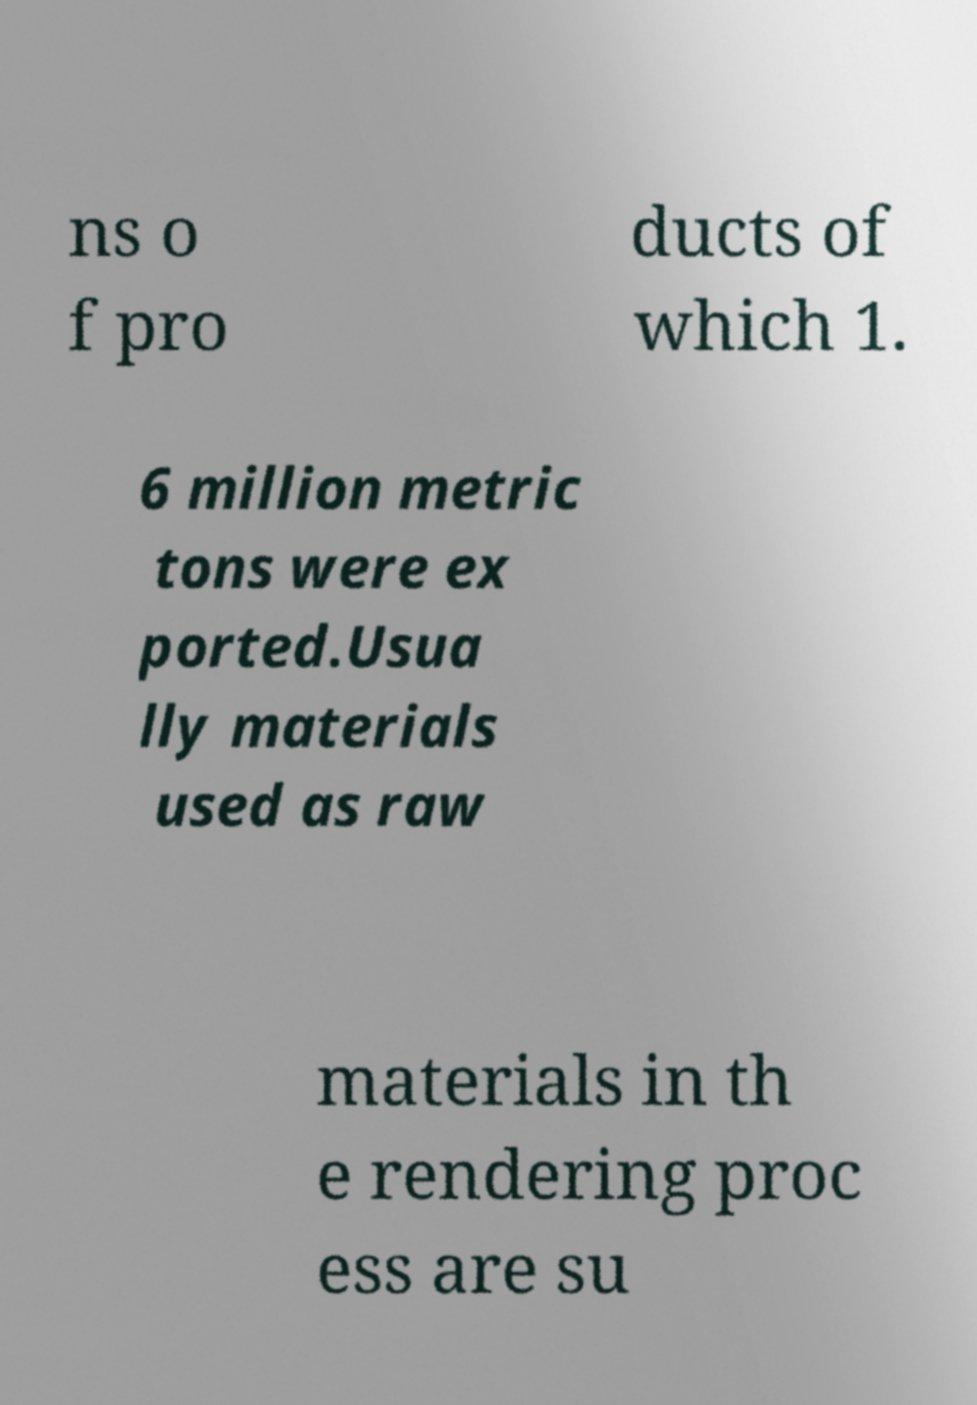Could you extract and type out the text from this image? ns o f pro ducts of which 1. 6 million metric tons were ex ported.Usua lly materials used as raw materials in th e rendering proc ess are su 